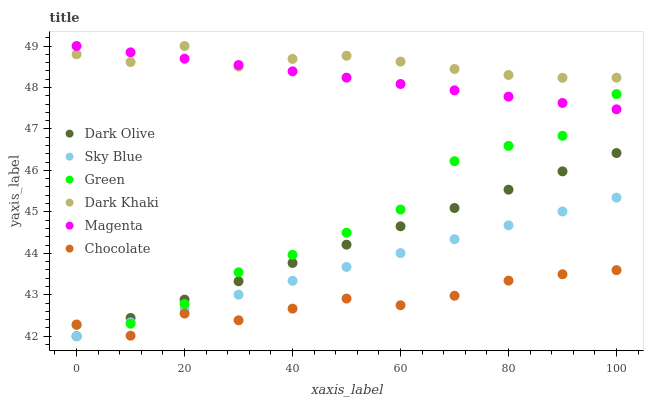Does Chocolate have the minimum area under the curve?
Answer yes or no. Yes. Does Dark Khaki have the maximum area under the curve?
Answer yes or no. Yes. Does Dark Khaki have the minimum area under the curve?
Answer yes or no. No. Does Chocolate have the maximum area under the curve?
Answer yes or no. No. Is Sky Blue the smoothest?
Answer yes or no. Yes. Is Green the roughest?
Answer yes or no. Yes. Is Chocolate the smoothest?
Answer yes or no. No. Is Chocolate the roughest?
Answer yes or no. No. Does Dark Olive have the lowest value?
Answer yes or no. Yes. Does Chocolate have the lowest value?
Answer yes or no. No. Does Magenta have the highest value?
Answer yes or no. Yes. Does Chocolate have the highest value?
Answer yes or no. No. Is Chocolate less than Magenta?
Answer yes or no. Yes. Is Dark Khaki greater than Sky Blue?
Answer yes or no. Yes. Does Sky Blue intersect Green?
Answer yes or no. Yes. Is Sky Blue less than Green?
Answer yes or no. No. Is Sky Blue greater than Green?
Answer yes or no. No. Does Chocolate intersect Magenta?
Answer yes or no. No. 